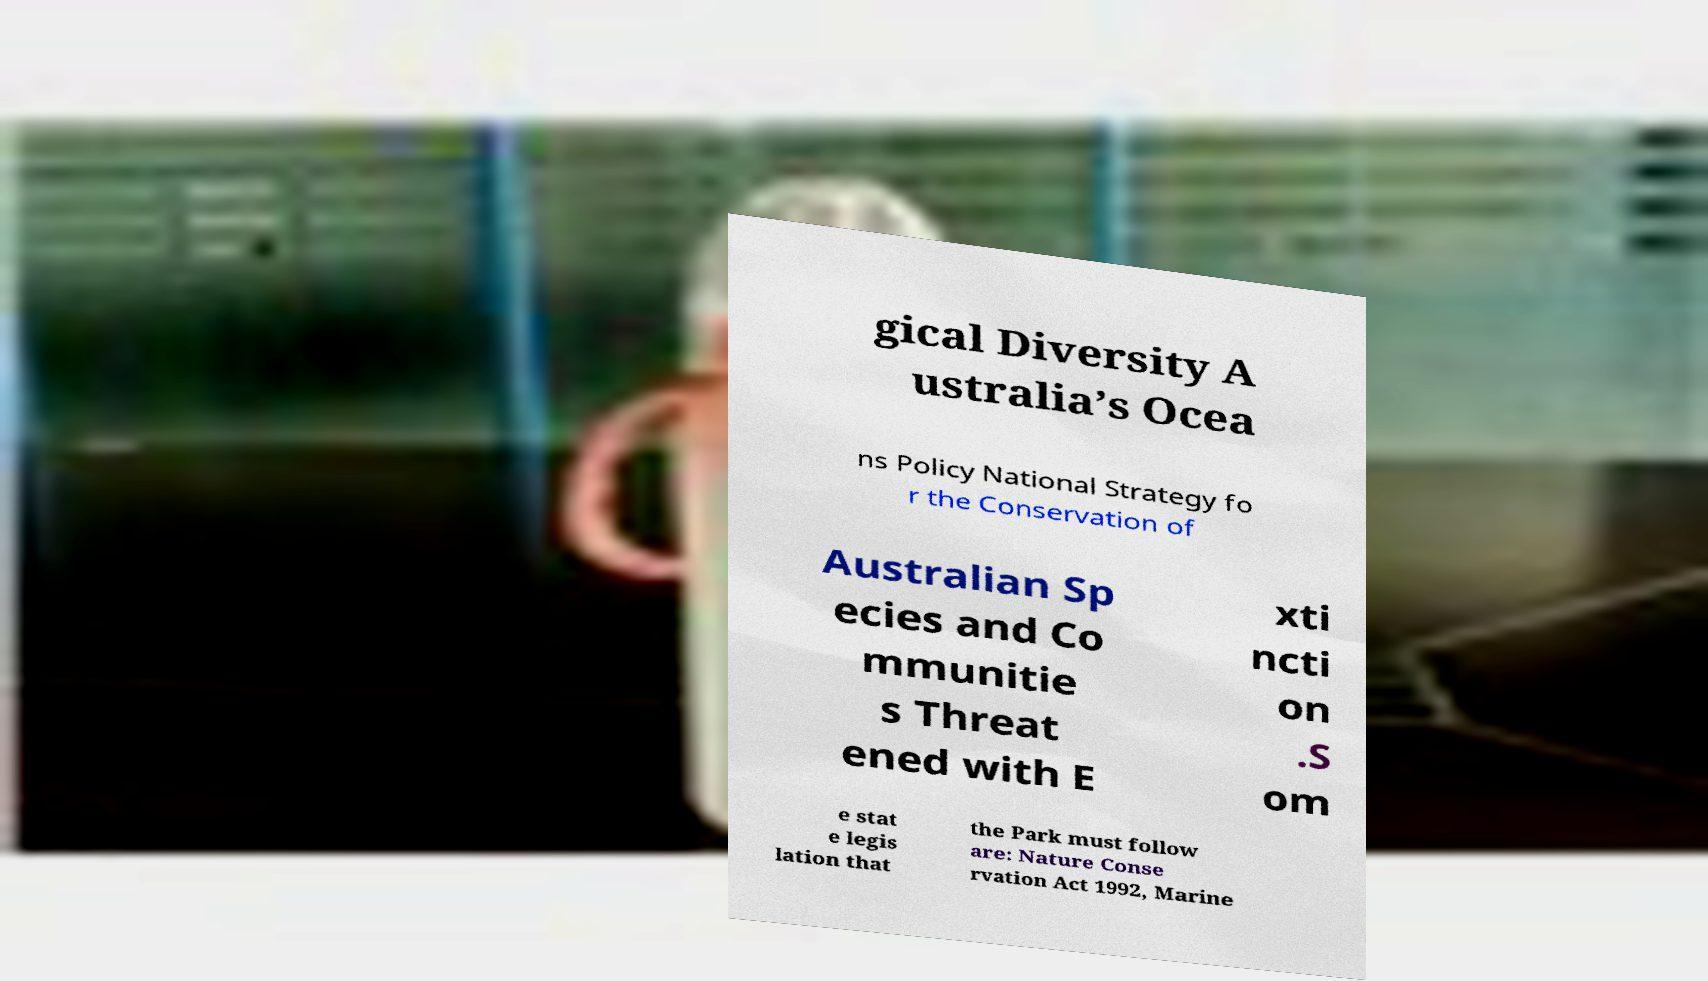Please identify and transcribe the text found in this image. gical Diversity A ustralia’s Ocea ns Policy National Strategy fo r the Conservation of Australian Sp ecies and Co mmunitie s Threat ened with E xti ncti on .S om e stat e legis lation that the Park must follow are: Nature Conse rvation Act 1992, Marine 